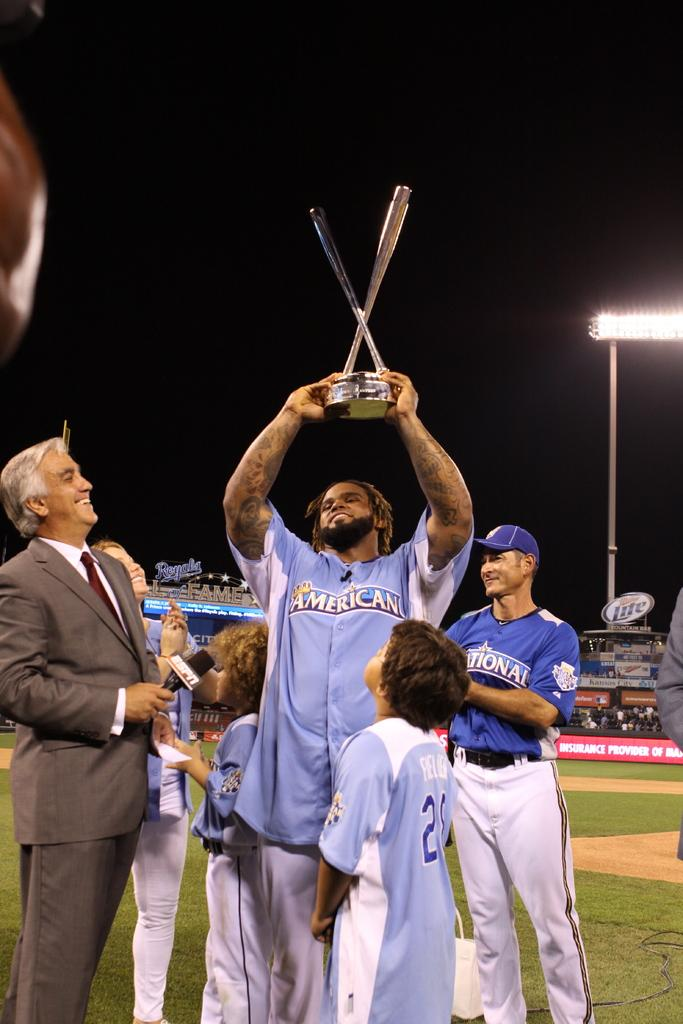<image>
Give a short and clear explanation of the subsequent image. Man holding a trophy and wearing a jersey that says American on it. 